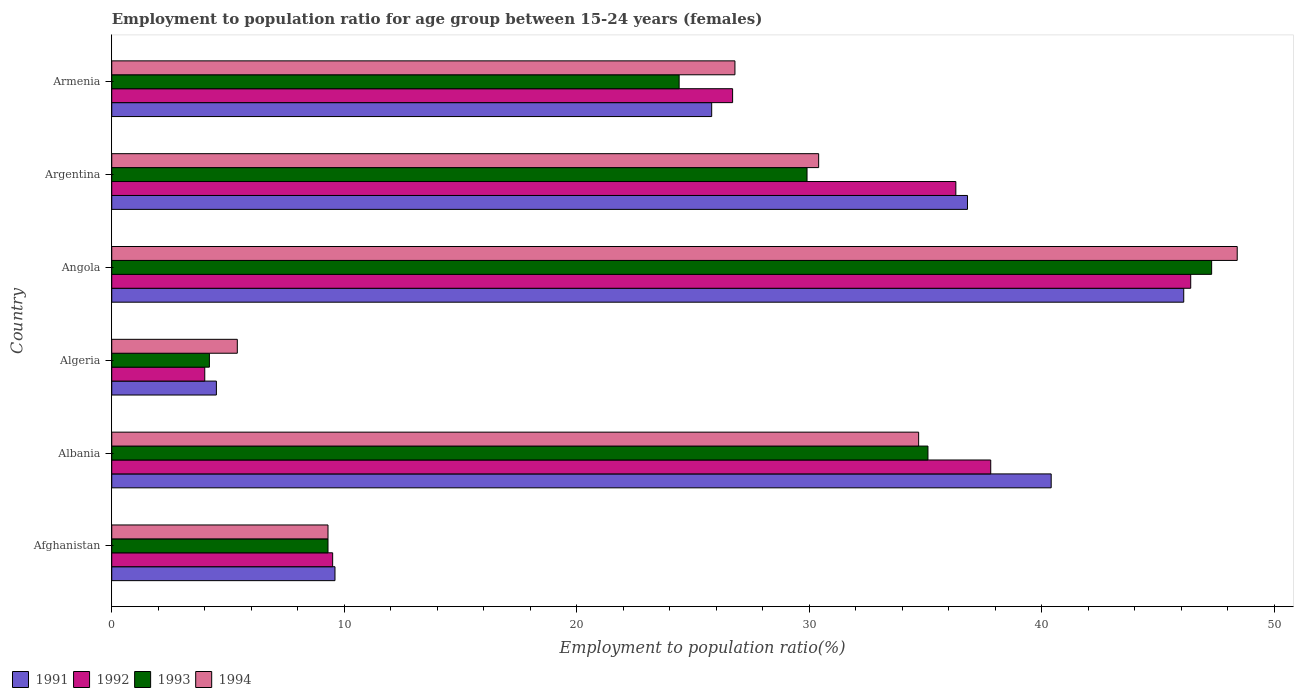Are the number of bars per tick equal to the number of legend labels?
Your response must be concise. Yes. How many bars are there on the 4th tick from the top?
Keep it short and to the point. 4. What is the label of the 6th group of bars from the top?
Your response must be concise. Afghanistan. What is the employment to population ratio in 1992 in Afghanistan?
Provide a short and direct response. 9.5. Across all countries, what is the maximum employment to population ratio in 1994?
Keep it short and to the point. 48.4. Across all countries, what is the minimum employment to population ratio in 1992?
Your answer should be very brief. 4. In which country was the employment to population ratio in 1992 maximum?
Offer a terse response. Angola. In which country was the employment to population ratio in 1994 minimum?
Provide a succinct answer. Algeria. What is the total employment to population ratio in 1993 in the graph?
Give a very brief answer. 150.2. What is the difference between the employment to population ratio in 1993 in Argentina and that in Armenia?
Make the answer very short. 5.5. What is the difference between the employment to population ratio in 1993 in Angola and the employment to population ratio in 1994 in Algeria?
Provide a short and direct response. 41.9. What is the average employment to population ratio in 1991 per country?
Ensure brevity in your answer.  27.2. What is the difference between the employment to population ratio in 1992 and employment to population ratio in 1994 in Argentina?
Your response must be concise. 5.9. What is the ratio of the employment to population ratio in 1994 in Angola to that in Argentina?
Give a very brief answer. 1.59. Is the difference between the employment to population ratio in 1992 in Algeria and Angola greater than the difference between the employment to population ratio in 1994 in Algeria and Angola?
Ensure brevity in your answer.  Yes. What is the difference between the highest and the second highest employment to population ratio in 1993?
Give a very brief answer. 12.2. What is the difference between the highest and the lowest employment to population ratio in 1994?
Give a very brief answer. 43. Is the sum of the employment to population ratio in 1994 in Algeria and Angola greater than the maximum employment to population ratio in 1993 across all countries?
Give a very brief answer. Yes. What does the 1st bar from the bottom in Afghanistan represents?
Keep it short and to the point. 1991. How many countries are there in the graph?
Provide a succinct answer. 6. What is the difference between two consecutive major ticks on the X-axis?
Make the answer very short. 10. Are the values on the major ticks of X-axis written in scientific E-notation?
Offer a very short reply. No. Does the graph contain grids?
Keep it short and to the point. No. Where does the legend appear in the graph?
Ensure brevity in your answer.  Bottom left. How are the legend labels stacked?
Offer a terse response. Horizontal. What is the title of the graph?
Your answer should be compact. Employment to population ratio for age group between 15-24 years (females). What is the label or title of the Y-axis?
Your answer should be compact. Country. What is the Employment to population ratio(%) in 1991 in Afghanistan?
Make the answer very short. 9.6. What is the Employment to population ratio(%) in 1993 in Afghanistan?
Your answer should be compact. 9.3. What is the Employment to population ratio(%) of 1994 in Afghanistan?
Make the answer very short. 9.3. What is the Employment to population ratio(%) in 1991 in Albania?
Offer a terse response. 40.4. What is the Employment to population ratio(%) in 1992 in Albania?
Your response must be concise. 37.8. What is the Employment to population ratio(%) of 1993 in Albania?
Your answer should be very brief. 35.1. What is the Employment to population ratio(%) of 1994 in Albania?
Provide a succinct answer. 34.7. What is the Employment to population ratio(%) in 1991 in Algeria?
Ensure brevity in your answer.  4.5. What is the Employment to population ratio(%) in 1993 in Algeria?
Make the answer very short. 4.2. What is the Employment to population ratio(%) in 1994 in Algeria?
Your answer should be very brief. 5.4. What is the Employment to population ratio(%) in 1991 in Angola?
Offer a terse response. 46.1. What is the Employment to population ratio(%) of 1992 in Angola?
Offer a terse response. 46.4. What is the Employment to population ratio(%) in 1993 in Angola?
Give a very brief answer. 47.3. What is the Employment to population ratio(%) in 1994 in Angola?
Ensure brevity in your answer.  48.4. What is the Employment to population ratio(%) in 1991 in Argentina?
Ensure brevity in your answer.  36.8. What is the Employment to population ratio(%) in 1992 in Argentina?
Make the answer very short. 36.3. What is the Employment to population ratio(%) of 1993 in Argentina?
Give a very brief answer. 29.9. What is the Employment to population ratio(%) of 1994 in Argentina?
Offer a terse response. 30.4. What is the Employment to population ratio(%) in 1991 in Armenia?
Offer a very short reply. 25.8. What is the Employment to population ratio(%) of 1992 in Armenia?
Provide a succinct answer. 26.7. What is the Employment to population ratio(%) in 1993 in Armenia?
Make the answer very short. 24.4. What is the Employment to population ratio(%) in 1994 in Armenia?
Offer a very short reply. 26.8. Across all countries, what is the maximum Employment to population ratio(%) in 1991?
Provide a short and direct response. 46.1. Across all countries, what is the maximum Employment to population ratio(%) in 1992?
Your answer should be compact. 46.4. Across all countries, what is the maximum Employment to population ratio(%) in 1993?
Your answer should be compact. 47.3. Across all countries, what is the maximum Employment to population ratio(%) of 1994?
Your response must be concise. 48.4. Across all countries, what is the minimum Employment to population ratio(%) of 1993?
Offer a terse response. 4.2. Across all countries, what is the minimum Employment to population ratio(%) of 1994?
Offer a very short reply. 5.4. What is the total Employment to population ratio(%) in 1991 in the graph?
Your answer should be very brief. 163.2. What is the total Employment to population ratio(%) in 1992 in the graph?
Offer a terse response. 160.7. What is the total Employment to population ratio(%) in 1993 in the graph?
Make the answer very short. 150.2. What is the total Employment to population ratio(%) in 1994 in the graph?
Your answer should be very brief. 155. What is the difference between the Employment to population ratio(%) of 1991 in Afghanistan and that in Albania?
Make the answer very short. -30.8. What is the difference between the Employment to population ratio(%) of 1992 in Afghanistan and that in Albania?
Provide a succinct answer. -28.3. What is the difference between the Employment to population ratio(%) in 1993 in Afghanistan and that in Albania?
Your answer should be compact. -25.8. What is the difference between the Employment to population ratio(%) in 1994 in Afghanistan and that in Albania?
Keep it short and to the point. -25.4. What is the difference between the Employment to population ratio(%) of 1991 in Afghanistan and that in Algeria?
Your answer should be very brief. 5.1. What is the difference between the Employment to population ratio(%) of 1991 in Afghanistan and that in Angola?
Keep it short and to the point. -36.5. What is the difference between the Employment to population ratio(%) of 1992 in Afghanistan and that in Angola?
Provide a succinct answer. -36.9. What is the difference between the Employment to population ratio(%) in 1993 in Afghanistan and that in Angola?
Provide a short and direct response. -38. What is the difference between the Employment to population ratio(%) in 1994 in Afghanistan and that in Angola?
Provide a succinct answer. -39.1. What is the difference between the Employment to population ratio(%) in 1991 in Afghanistan and that in Argentina?
Provide a short and direct response. -27.2. What is the difference between the Employment to population ratio(%) of 1992 in Afghanistan and that in Argentina?
Provide a short and direct response. -26.8. What is the difference between the Employment to population ratio(%) in 1993 in Afghanistan and that in Argentina?
Give a very brief answer. -20.6. What is the difference between the Employment to population ratio(%) in 1994 in Afghanistan and that in Argentina?
Provide a short and direct response. -21.1. What is the difference between the Employment to population ratio(%) in 1991 in Afghanistan and that in Armenia?
Ensure brevity in your answer.  -16.2. What is the difference between the Employment to population ratio(%) of 1992 in Afghanistan and that in Armenia?
Ensure brevity in your answer.  -17.2. What is the difference between the Employment to population ratio(%) in 1993 in Afghanistan and that in Armenia?
Provide a short and direct response. -15.1. What is the difference between the Employment to population ratio(%) of 1994 in Afghanistan and that in Armenia?
Provide a succinct answer. -17.5. What is the difference between the Employment to population ratio(%) in 1991 in Albania and that in Algeria?
Your response must be concise. 35.9. What is the difference between the Employment to population ratio(%) of 1992 in Albania and that in Algeria?
Ensure brevity in your answer.  33.8. What is the difference between the Employment to population ratio(%) of 1993 in Albania and that in Algeria?
Ensure brevity in your answer.  30.9. What is the difference between the Employment to population ratio(%) of 1994 in Albania and that in Algeria?
Offer a very short reply. 29.3. What is the difference between the Employment to population ratio(%) of 1991 in Albania and that in Angola?
Your answer should be compact. -5.7. What is the difference between the Employment to population ratio(%) in 1992 in Albania and that in Angola?
Give a very brief answer. -8.6. What is the difference between the Employment to population ratio(%) of 1993 in Albania and that in Angola?
Your answer should be compact. -12.2. What is the difference between the Employment to population ratio(%) in 1994 in Albania and that in Angola?
Offer a very short reply. -13.7. What is the difference between the Employment to population ratio(%) in 1994 in Albania and that in Argentina?
Ensure brevity in your answer.  4.3. What is the difference between the Employment to population ratio(%) in 1991 in Algeria and that in Angola?
Offer a very short reply. -41.6. What is the difference between the Employment to population ratio(%) in 1992 in Algeria and that in Angola?
Provide a succinct answer. -42.4. What is the difference between the Employment to population ratio(%) in 1993 in Algeria and that in Angola?
Offer a terse response. -43.1. What is the difference between the Employment to population ratio(%) of 1994 in Algeria and that in Angola?
Your response must be concise. -43. What is the difference between the Employment to population ratio(%) of 1991 in Algeria and that in Argentina?
Offer a very short reply. -32.3. What is the difference between the Employment to population ratio(%) in 1992 in Algeria and that in Argentina?
Ensure brevity in your answer.  -32.3. What is the difference between the Employment to population ratio(%) in 1993 in Algeria and that in Argentina?
Make the answer very short. -25.7. What is the difference between the Employment to population ratio(%) in 1991 in Algeria and that in Armenia?
Ensure brevity in your answer.  -21.3. What is the difference between the Employment to population ratio(%) in 1992 in Algeria and that in Armenia?
Make the answer very short. -22.7. What is the difference between the Employment to population ratio(%) in 1993 in Algeria and that in Armenia?
Offer a terse response. -20.2. What is the difference between the Employment to population ratio(%) in 1994 in Algeria and that in Armenia?
Your response must be concise. -21.4. What is the difference between the Employment to population ratio(%) of 1991 in Angola and that in Argentina?
Provide a succinct answer. 9.3. What is the difference between the Employment to population ratio(%) of 1992 in Angola and that in Argentina?
Offer a very short reply. 10.1. What is the difference between the Employment to population ratio(%) of 1993 in Angola and that in Argentina?
Make the answer very short. 17.4. What is the difference between the Employment to population ratio(%) in 1991 in Angola and that in Armenia?
Keep it short and to the point. 20.3. What is the difference between the Employment to population ratio(%) in 1992 in Angola and that in Armenia?
Provide a succinct answer. 19.7. What is the difference between the Employment to population ratio(%) of 1993 in Angola and that in Armenia?
Offer a very short reply. 22.9. What is the difference between the Employment to population ratio(%) in 1994 in Angola and that in Armenia?
Make the answer very short. 21.6. What is the difference between the Employment to population ratio(%) of 1991 in Argentina and that in Armenia?
Your answer should be very brief. 11. What is the difference between the Employment to population ratio(%) in 1992 in Argentina and that in Armenia?
Offer a terse response. 9.6. What is the difference between the Employment to population ratio(%) of 1993 in Argentina and that in Armenia?
Keep it short and to the point. 5.5. What is the difference between the Employment to population ratio(%) in 1994 in Argentina and that in Armenia?
Make the answer very short. 3.6. What is the difference between the Employment to population ratio(%) of 1991 in Afghanistan and the Employment to population ratio(%) of 1992 in Albania?
Make the answer very short. -28.2. What is the difference between the Employment to population ratio(%) in 1991 in Afghanistan and the Employment to population ratio(%) in 1993 in Albania?
Make the answer very short. -25.5. What is the difference between the Employment to population ratio(%) in 1991 in Afghanistan and the Employment to population ratio(%) in 1994 in Albania?
Provide a short and direct response. -25.1. What is the difference between the Employment to population ratio(%) of 1992 in Afghanistan and the Employment to population ratio(%) of 1993 in Albania?
Your answer should be very brief. -25.6. What is the difference between the Employment to population ratio(%) of 1992 in Afghanistan and the Employment to population ratio(%) of 1994 in Albania?
Give a very brief answer. -25.2. What is the difference between the Employment to population ratio(%) of 1993 in Afghanistan and the Employment to population ratio(%) of 1994 in Albania?
Offer a terse response. -25.4. What is the difference between the Employment to population ratio(%) of 1991 in Afghanistan and the Employment to population ratio(%) of 1994 in Algeria?
Ensure brevity in your answer.  4.2. What is the difference between the Employment to population ratio(%) in 1991 in Afghanistan and the Employment to population ratio(%) in 1992 in Angola?
Keep it short and to the point. -36.8. What is the difference between the Employment to population ratio(%) of 1991 in Afghanistan and the Employment to population ratio(%) of 1993 in Angola?
Provide a succinct answer. -37.7. What is the difference between the Employment to population ratio(%) in 1991 in Afghanistan and the Employment to population ratio(%) in 1994 in Angola?
Make the answer very short. -38.8. What is the difference between the Employment to population ratio(%) in 1992 in Afghanistan and the Employment to population ratio(%) in 1993 in Angola?
Offer a very short reply. -37.8. What is the difference between the Employment to population ratio(%) of 1992 in Afghanistan and the Employment to population ratio(%) of 1994 in Angola?
Your answer should be very brief. -38.9. What is the difference between the Employment to population ratio(%) of 1993 in Afghanistan and the Employment to population ratio(%) of 1994 in Angola?
Offer a very short reply. -39.1. What is the difference between the Employment to population ratio(%) of 1991 in Afghanistan and the Employment to population ratio(%) of 1992 in Argentina?
Your answer should be compact. -26.7. What is the difference between the Employment to population ratio(%) of 1991 in Afghanistan and the Employment to population ratio(%) of 1993 in Argentina?
Provide a succinct answer. -20.3. What is the difference between the Employment to population ratio(%) of 1991 in Afghanistan and the Employment to population ratio(%) of 1994 in Argentina?
Offer a terse response. -20.8. What is the difference between the Employment to population ratio(%) in 1992 in Afghanistan and the Employment to population ratio(%) in 1993 in Argentina?
Provide a short and direct response. -20.4. What is the difference between the Employment to population ratio(%) of 1992 in Afghanistan and the Employment to population ratio(%) of 1994 in Argentina?
Make the answer very short. -20.9. What is the difference between the Employment to population ratio(%) in 1993 in Afghanistan and the Employment to population ratio(%) in 1994 in Argentina?
Offer a very short reply. -21.1. What is the difference between the Employment to population ratio(%) in 1991 in Afghanistan and the Employment to population ratio(%) in 1992 in Armenia?
Provide a succinct answer. -17.1. What is the difference between the Employment to population ratio(%) in 1991 in Afghanistan and the Employment to population ratio(%) in 1993 in Armenia?
Provide a succinct answer. -14.8. What is the difference between the Employment to population ratio(%) of 1991 in Afghanistan and the Employment to population ratio(%) of 1994 in Armenia?
Your answer should be very brief. -17.2. What is the difference between the Employment to population ratio(%) of 1992 in Afghanistan and the Employment to population ratio(%) of 1993 in Armenia?
Your answer should be compact. -14.9. What is the difference between the Employment to population ratio(%) in 1992 in Afghanistan and the Employment to population ratio(%) in 1994 in Armenia?
Make the answer very short. -17.3. What is the difference between the Employment to population ratio(%) in 1993 in Afghanistan and the Employment to population ratio(%) in 1994 in Armenia?
Ensure brevity in your answer.  -17.5. What is the difference between the Employment to population ratio(%) in 1991 in Albania and the Employment to population ratio(%) in 1992 in Algeria?
Your answer should be very brief. 36.4. What is the difference between the Employment to population ratio(%) of 1991 in Albania and the Employment to population ratio(%) of 1993 in Algeria?
Offer a very short reply. 36.2. What is the difference between the Employment to population ratio(%) of 1991 in Albania and the Employment to population ratio(%) of 1994 in Algeria?
Provide a succinct answer. 35. What is the difference between the Employment to population ratio(%) in 1992 in Albania and the Employment to population ratio(%) in 1993 in Algeria?
Your answer should be compact. 33.6. What is the difference between the Employment to population ratio(%) of 1992 in Albania and the Employment to population ratio(%) of 1994 in Algeria?
Provide a succinct answer. 32.4. What is the difference between the Employment to population ratio(%) in 1993 in Albania and the Employment to population ratio(%) in 1994 in Algeria?
Your answer should be compact. 29.7. What is the difference between the Employment to population ratio(%) in 1991 in Albania and the Employment to population ratio(%) in 1992 in Angola?
Your answer should be compact. -6. What is the difference between the Employment to population ratio(%) of 1991 in Albania and the Employment to population ratio(%) of 1992 in Armenia?
Make the answer very short. 13.7. What is the difference between the Employment to population ratio(%) of 1991 in Algeria and the Employment to population ratio(%) of 1992 in Angola?
Your answer should be compact. -41.9. What is the difference between the Employment to population ratio(%) of 1991 in Algeria and the Employment to population ratio(%) of 1993 in Angola?
Give a very brief answer. -42.8. What is the difference between the Employment to population ratio(%) of 1991 in Algeria and the Employment to population ratio(%) of 1994 in Angola?
Offer a very short reply. -43.9. What is the difference between the Employment to population ratio(%) in 1992 in Algeria and the Employment to population ratio(%) in 1993 in Angola?
Provide a short and direct response. -43.3. What is the difference between the Employment to population ratio(%) of 1992 in Algeria and the Employment to population ratio(%) of 1994 in Angola?
Offer a very short reply. -44.4. What is the difference between the Employment to population ratio(%) of 1993 in Algeria and the Employment to population ratio(%) of 1994 in Angola?
Provide a short and direct response. -44.2. What is the difference between the Employment to population ratio(%) of 1991 in Algeria and the Employment to population ratio(%) of 1992 in Argentina?
Provide a succinct answer. -31.8. What is the difference between the Employment to population ratio(%) of 1991 in Algeria and the Employment to population ratio(%) of 1993 in Argentina?
Your response must be concise. -25.4. What is the difference between the Employment to population ratio(%) in 1991 in Algeria and the Employment to population ratio(%) in 1994 in Argentina?
Ensure brevity in your answer.  -25.9. What is the difference between the Employment to population ratio(%) in 1992 in Algeria and the Employment to population ratio(%) in 1993 in Argentina?
Provide a short and direct response. -25.9. What is the difference between the Employment to population ratio(%) of 1992 in Algeria and the Employment to population ratio(%) of 1994 in Argentina?
Offer a very short reply. -26.4. What is the difference between the Employment to population ratio(%) in 1993 in Algeria and the Employment to population ratio(%) in 1994 in Argentina?
Give a very brief answer. -26.2. What is the difference between the Employment to population ratio(%) in 1991 in Algeria and the Employment to population ratio(%) in 1992 in Armenia?
Offer a very short reply. -22.2. What is the difference between the Employment to population ratio(%) in 1991 in Algeria and the Employment to population ratio(%) in 1993 in Armenia?
Provide a short and direct response. -19.9. What is the difference between the Employment to population ratio(%) of 1991 in Algeria and the Employment to population ratio(%) of 1994 in Armenia?
Your answer should be compact. -22.3. What is the difference between the Employment to population ratio(%) in 1992 in Algeria and the Employment to population ratio(%) in 1993 in Armenia?
Your answer should be very brief. -20.4. What is the difference between the Employment to population ratio(%) in 1992 in Algeria and the Employment to population ratio(%) in 1994 in Armenia?
Your response must be concise. -22.8. What is the difference between the Employment to population ratio(%) of 1993 in Algeria and the Employment to population ratio(%) of 1994 in Armenia?
Offer a terse response. -22.6. What is the difference between the Employment to population ratio(%) of 1991 in Angola and the Employment to population ratio(%) of 1992 in Argentina?
Your answer should be very brief. 9.8. What is the difference between the Employment to population ratio(%) in 1991 in Angola and the Employment to population ratio(%) in 1993 in Argentina?
Keep it short and to the point. 16.2. What is the difference between the Employment to population ratio(%) in 1991 in Angola and the Employment to population ratio(%) in 1994 in Argentina?
Provide a succinct answer. 15.7. What is the difference between the Employment to population ratio(%) of 1992 in Angola and the Employment to population ratio(%) of 1993 in Argentina?
Offer a terse response. 16.5. What is the difference between the Employment to population ratio(%) in 1991 in Angola and the Employment to population ratio(%) in 1992 in Armenia?
Provide a short and direct response. 19.4. What is the difference between the Employment to population ratio(%) of 1991 in Angola and the Employment to population ratio(%) of 1993 in Armenia?
Keep it short and to the point. 21.7. What is the difference between the Employment to population ratio(%) of 1991 in Angola and the Employment to population ratio(%) of 1994 in Armenia?
Give a very brief answer. 19.3. What is the difference between the Employment to population ratio(%) in 1992 in Angola and the Employment to population ratio(%) in 1994 in Armenia?
Make the answer very short. 19.6. What is the difference between the Employment to population ratio(%) of 1991 in Argentina and the Employment to population ratio(%) of 1992 in Armenia?
Give a very brief answer. 10.1. What is the average Employment to population ratio(%) in 1991 per country?
Ensure brevity in your answer.  27.2. What is the average Employment to population ratio(%) in 1992 per country?
Give a very brief answer. 26.78. What is the average Employment to population ratio(%) in 1993 per country?
Your response must be concise. 25.03. What is the average Employment to population ratio(%) in 1994 per country?
Keep it short and to the point. 25.83. What is the difference between the Employment to population ratio(%) in 1991 and Employment to population ratio(%) in 1992 in Afghanistan?
Ensure brevity in your answer.  0.1. What is the difference between the Employment to population ratio(%) of 1991 and Employment to population ratio(%) of 1994 in Afghanistan?
Offer a terse response. 0.3. What is the difference between the Employment to population ratio(%) in 1992 and Employment to population ratio(%) in 1994 in Afghanistan?
Provide a short and direct response. 0.2. What is the difference between the Employment to population ratio(%) of 1993 and Employment to population ratio(%) of 1994 in Afghanistan?
Offer a terse response. 0. What is the difference between the Employment to population ratio(%) of 1991 and Employment to population ratio(%) of 1992 in Albania?
Offer a very short reply. 2.6. What is the difference between the Employment to population ratio(%) in 1991 and Employment to population ratio(%) in 1993 in Albania?
Your response must be concise. 5.3. What is the difference between the Employment to population ratio(%) of 1991 and Employment to population ratio(%) of 1994 in Albania?
Your response must be concise. 5.7. What is the difference between the Employment to population ratio(%) of 1992 and Employment to population ratio(%) of 1993 in Albania?
Your response must be concise. 2.7. What is the difference between the Employment to population ratio(%) of 1991 and Employment to population ratio(%) of 1993 in Algeria?
Your response must be concise. 0.3. What is the difference between the Employment to population ratio(%) of 1991 and Employment to population ratio(%) of 1994 in Algeria?
Give a very brief answer. -0.9. What is the difference between the Employment to population ratio(%) of 1991 and Employment to population ratio(%) of 1993 in Angola?
Offer a very short reply. -1.2. What is the difference between the Employment to population ratio(%) of 1992 and Employment to population ratio(%) of 1994 in Angola?
Offer a very short reply. -2. What is the difference between the Employment to population ratio(%) in 1991 and Employment to population ratio(%) in 1992 in Argentina?
Offer a terse response. 0.5. What is the difference between the Employment to population ratio(%) in 1991 and Employment to population ratio(%) in 1993 in Argentina?
Provide a succinct answer. 6.9. What is the difference between the Employment to population ratio(%) in 1991 and Employment to population ratio(%) in 1994 in Argentina?
Make the answer very short. 6.4. What is the difference between the Employment to population ratio(%) of 1992 and Employment to population ratio(%) of 1994 in Argentina?
Keep it short and to the point. 5.9. What is the difference between the Employment to population ratio(%) in 1993 and Employment to population ratio(%) in 1994 in Argentina?
Your answer should be very brief. -0.5. What is the difference between the Employment to population ratio(%) in 1991 and Employment to population ratio(%) in 1992 in Armenia?
Keep it short and to the point. -0.9. What is the difference between the Employment to population ratio(%) in 1991 and Employment to population ratio(%) in 1993 in Armenia?
Your response must be concise. 1.4. What is the difference between the Employment to population ratio(%) in 1991 and Employment to population ratio(%) in 1994 in Armenia?
Give a very brief answer. -1. What is the difference between the Employment to population ratio(%) in 1992 and Employment to population ratio(%) in 1993 in Armenia?
Keep it short and to the point. 2.3. What is the difference between the Employment to population ratio(%) of 1993 and Employment to population ratio(%) of 1994 in Armenia?
Your answer should be compact. -2.4. What is the ratio of the Employment to population ratio(%) in 1991 in Afghanistan to that in Albania?
Provide a succinct answer. 0.24. What is the ratio of the Employment to population ratio(%) in 1992 in Afghanistan to that in Albania?
Offer a very short reply. 0.25. What is the ratio of the Employment to population ratio(%) of 1993 in Afghanistan to that in Albania?
Ensure brevity in your answer.  0.27. What is the ratio of the Employment to population ratio(%) in 1994 in Afghanistan to that in Albania?
Offer a terse response. 0.27. What is the ratio of the Employment to population ratio(%) of 1991 in Afghanistan to that in Algeria?
Your response must be concise. 2.13. What is the ratio of the Employment to population ratio(%) in 1992 in Afghanistan to that in Algeria?
Your answer should be compact. 2.38. What is the ratio of the Employment to population ratio(%) in 1993 in Afghanistan to that in Algeria?
Provide a short and direct response. 2.21. What is the ratio of the Employment to population ratio(%) of 1994 in Afghanistan to that in Algeria?
Provide a succinct answer. 1.72. What is the ratio of the Employment to population ratio(%) in 1991 in Afghanistan to that in Angola?
Provide a succinct answer. 0.21. What is the ratio of the Employment to population ratio(%) in 1992 in Afghanistan to that in Angola?
Offer a very short reply. 0.2. What is the ratio of the Employment to population ratio(%) in 1993 in Afghanistan to that in Angola?
Your answer should be compact. 0.2. What is the ratio of the Employment to population ratio(%) in 1994 in Afghanistan to that in Angola?
Make the answer very short. 0.19. What is the ratio of the Employment to population ratio(%) in 1991 in Afghanistan to that in Argentina?
Offer a terse response. 0.26. What is the ratio of the Employment to population ratio(%) in 1992 in Afghanistan to that in Argentina?
Offer a terse response. 0.26. What is the ratio of the Employment to population ratio(%) in 1993 in Afghanistan to that in Argentina?
Give a very brief answer. 0.31. What is the ratio of the Employment to population ratio(%) of 1994 in Afghanistan to that in Argentina?
Provide a short and direct response. 0.31. What is the ratio of the Employment to population ratio(%) in 1991 in Afghanistan to that in Armenia?
Provide a short and direct response. 0.37. What is the ratio of the Employment to population ratio(%) in 1992 in Afghanistan to that in Armenia?
Your response must be concise. 0.36. What is the ratio of the Employment to population ratio(%) of 1993 in Afghanistan to that in Armenia?
Ensure brevity in your answer.  0.38. What is the ratio of the Employment to population ratio(%) of 1994 in Afghanistan to that in Armenia?
Offer a very short reply. 0.35. What is the ratio of the Employment to population ratio(%) of 1991 in Albania to that in Algeria?
Offer a terse response. 8.98. What is the ratio of the Employment to population ratio(%) in 1992 in Albania to that in Algeria?
Provide a succinct answer. 9.45. What is the ratio of the Employment to population ratio(%) in 1993 in Albania to that in Algeria?
Offer a very short reply. 8.36. What is the ratio of the Employment to population ratio(%) of 1994 in Albania to that in Algeria?
Your response must be concise. 6.43. What is the ratio of the Employment to population ratio(%) of 1991 in Albania to that in Angola?
Your answer should be compact. 0.88. What is the ratio of the Employment to population ratio(%) in 1992 in Albania to that in Angola?
Make the answer very short. 0.81. What is the ratio of the Employment to population ratio(%) in 1993 in Albania to that in Angola?
Provide a succinct answer. 0.74. What is the ratio of the Employment to population ratio(%) in 1994 in Albania to that in Angola?
Your response must be concise. 0.72. What is the ratio of the Employment to population ratio(%) of 1991 in Albania to that in Argentina?
Your response must be concise. 1.1. What is the ratio of the Employment to population ratio(%) of 1992 in Albania to that in Argentina?
Make the answer very short. 1.04. What is the ratio of the Employment to population ratio(%) of 1993 in Albania to that in Argentina?
Offer a terse response. 1.17. What is the ratio of the Employment to population ratio(%) of 1994 in Albania to that in Argentina?
Provide a succinct answer. 1.14. What is the ratio of the Employment to population ratio(%) of 1991 in Albania to that in Armenia?
Your response must be concise. 1.57. What is the ratio of the Employment to population ratio(%) of 1992 in Albania to that in Armenia?
Ensure brevity in your answer.  1.42. What is the ratio of the Employment to population ratio(%) of 1993 in Albania to that in Armenia?
Your answer should be compact. 1.44. What is the ratio of the Employment to population ratio(%) of 1994 in Albania to that in Armenia?
Offer a very short reply. 1.29. What is the ratio of the Employment to population ratio(%) of 1991 in Algeria to that in Angola?
Offer a terse response. 0.1. What is the ratio of the Employment to population ratio(%) of 1992 in Algeria to that in Angola?
Your answer should be compact. 0.09. What is the ratio of the Employment to population ratio(%) of 1993 in Algeria to that in Angola?
Offer a very short reply. 0.09. What is the ratio of the Employment to population ratio(%) of 1994 in Algeria to that in Angola?
Ensure brevity in your answer.  0.11. What is the ratio of the Employment to population ratio(%) in 1991 in Algeria to that in Argentina?
Make the answer very short. 0.12. What is the ratio of the Employment to population ratio(%) in 1992 in Algeria to that in Argentina?
Keep it short and to the point. 0.11. What is the ratio of the Employment to population ratio(%) of 1993 in Algeria to that in Argentina?
Ensure brevity in your answer.  0.14. What is the ratio of the Employment to population ratio(%) of 1994 in Algeria to that in Argentina?
Offer a terse response. 0.18. What is the ratio of the Employment to population ratio(%) in 1991 in Algeria to that in Armenia?
Give a very brief answer. 0.17. What is the ratio of the Employment to population ratio(%) in 1992 in Algeria to that in Armenia?
Offer a terse response. 0.15. What is the ratio of the Employment to population ratio(%) of 1993 in Algeria to that in Armenia?
Offer a very short reply. 0.17. What is the ratio of the Employment to population ratio(%) of 1994 in Algeria to that in Armenia?
Provide a succinct answer. 0.2. What is the ratio of the Employment to population ratio(%) in 1991 in Angola to that in Argentina?
Make the answer very short. 1.25. What is the ratio of the Employment to population ratio(%) in 1992 in Angola to that in Argentina?
Ensure brevity in your answer.  1.28. What is the ratio of the Employment to population ratio(%) of 1993 in Angola to that in Argentina?
Keep it short and to the point. 1.58. What is the ratio of the Employment to population ratio(%) in 1994 in Angola to that in Argentina?
Provide a succinct answer. 1.59. What is the ratio of the Employment to population ratio(%) in 1991 in Angola to that in Armenia?
Provide a succinct answer. 1.79. What is the ratio of the Employment to population ratio(%) of 1992 in Angola to that in Armenia?
Your answer should be very brief. 1.74. What is the ratio of the Employment to population ratio(%) in 1993 in Angola to that in Armenia?
Offer a very short reply. 1.94. What is the ratio of the Employment to population ratio(%) in 1994 in Angola to that in Armenia?
Ensure brevity in your answer.  1.81. What is the ratio of the Employment to population ratio(%) in 1991 in Argentina to that in Armenia?
Your answer should be very brief. 1.43. What is the ratio of the Employment to population ratio(%) of 1992 in Argentina to that in Armenia?
Offer a terse response. 1.36. What is the ratio of the Employment to population ratio(%) of 1993 in Argentina to that in Armenia?
Give a very brief answer. 1.23. What is the ratio of the Employment to population ratio(%) in 1994 in Argentina to that in Armenia?
Offer a very short reply. 1.13. What is the difference between the highest and the second highest Employment to population ratio(%) of 1992?
Provide a short and direct response. 8.6. What is the difference between the highest and the second highest Employment to population ratio(%) of 1993?
Give a very brief answer. 12.2. What is the difference between the highest and the second highest Employment to population ratio(%) of 1994?
Give a very brief answer. 13.7. What is the difference between the highest and the lowest Employment to population ratio(%) of 1991?
Offer a terse response. 41.6. What is the difference between the highest and the lowest Employment to population ratio(%) in 1992?
Offer a terse response. 42.4. What is the difference between the highest and the lowest Employment to population ratio(%) in 1993?
Provide a short and direct response. 43.1. What is the difference between the highest and the lowest Employment to population ratio(%) in 1994?
Offer a very short reply. 43. 